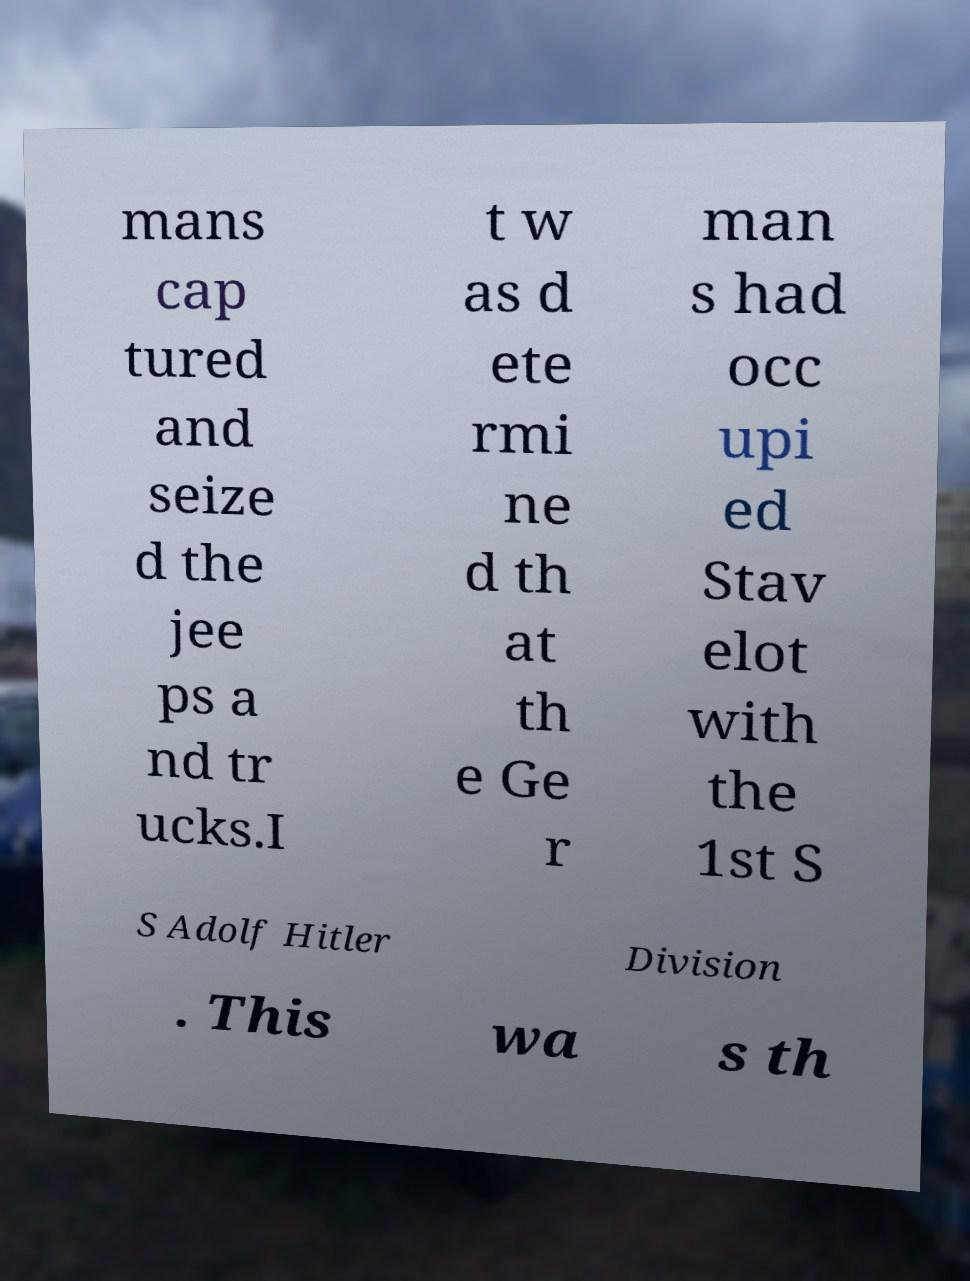Please read and relay the text visible in this image. What does it say? mans cap tured and seize d the jee ps a nd tr ucks.I t w as d ete rmi ne d th at th e Ge r man s had occ upi ed Stav elot with the 1st S S Adolf Hitler Division . This wa s th 